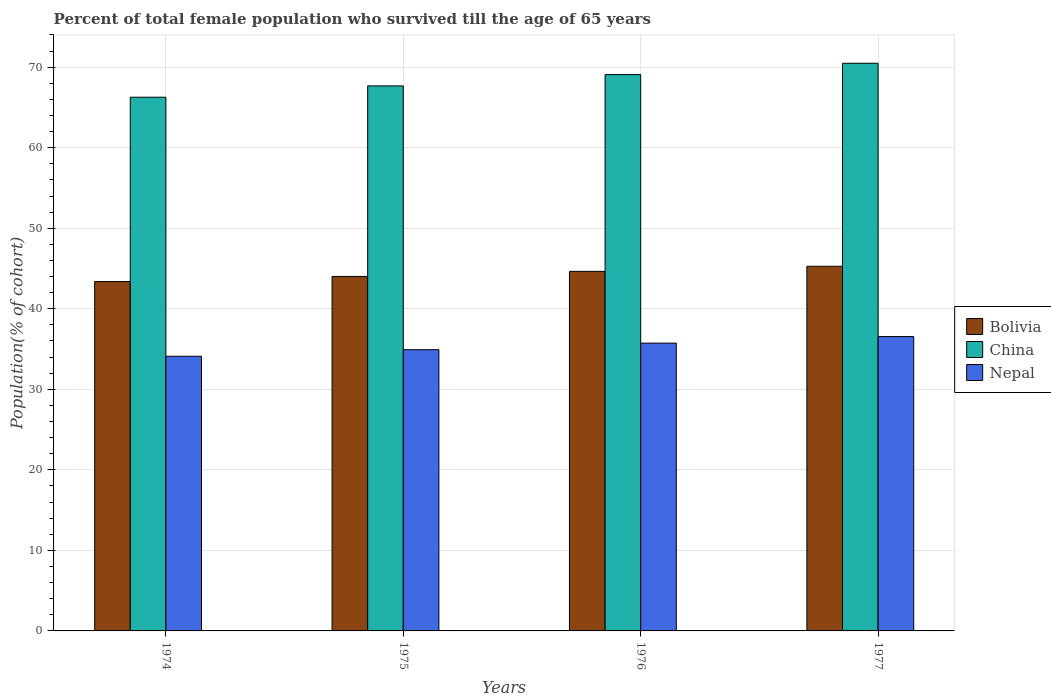Are the number of bars per tick equal to the number of legend labels?
Keep it short and to the point. Yes. Are the number of bars on each tick of the X-axis equal?
Offer a very short reply. Yes. How many bars are there on the 3rd tick from the right?
Make the answer very short. 3. What is the label of the 1st group of bars from the left?
Keep it short and to the point. 1974. In how many cases, is the number of bars for a given year not equal to the number of legend labels?
Keep it short and to the point. 0. What is the percentage of total female population who survived till the age of 65 years in China in 1976?
Offer a very short reply. 69.08. Across all years, what is the maximum percentage of total female population who survived till the age of 65 years in Bolivia?
Your answer should be compact. 45.27. Across all years, what is the minimum percentage of total female population who survived till the age of 65 years in Nepal?
Make the answer very short. 34.1. In which year was the percentage of total female population who survived till the age of 65 years in China minimum?
Provide a succinct answer. 1974. What is the total percentage of total female population who survived till the age of 65 years in Bolivia in the graph?
Your answer should be compact. 177.31. What is the difference between the percentage of total female population who survived till the age of 65 years in China in 1976 and that in 1977?
Give a very brief answer. -1.41. What is the difference between the percentage of total female population who survived till the age of 65 years in Nepal in 1977 and the percentage of total female population who survived till the age of 65 years in Bolivia in 1974?
Your answer should be very brief. -6.83. What is the average percentage of total female population who survived till the age of 65 years in Nepal per year?
Keep it short and to the point. 35.33. In the year 1974, what is the difference between the percentage of total female population who survived till the age of 65 years in Nepal and percentage of total female population who survived till the age of 65 years in China?
Your response must be concise. -32.16. What is the ratio of the percentage of total female population who survived till the age of 65 years in Bolivia in 1974 to that in 1975?
Provide a short and direct response. 0.99. Is the difference between the percentage of total female population who survived till the age of 65 years in Nepal in 1974 and 1975 greater than the difference between the percentage of total female population who survived till the age of 65 years in China in 1974 and 1975?
Ensure brevity in your answer.  Yes. What is the difference between the highest and the second highest percentage of total female population who survived till the age of 65 years in China?
Make the answer very short. 1.41. What is the difference between the highest and the lowest percentage of total female population who survived till the age of 65 years in Bolivia?
Your answer should be very brief. 1.89. In how many years, is the percentage of total female population who survived till the age of 65 years in Nepal greater than the average percentage of total female population who survived till the age of 65 years in Nepal taken over all years?
Your answer should be very brief. 2. Is the sum of the percentage of total female population who survived till the age of 65 years in Bolivia in 1975 and 1976 greater than the maximum percentage of total female population who survived till the age of 65 years in China across all years?
Keep it short and to the point. Yes. What does the 1st bar from the left in 1975 represents?
Ensure brevity in your answer.  Bolivia. What does the 3rd bar from the right in 1977 represents?
Your answer should be compact. Bolivia. Is it the case that in every year, the sum of the percentage of total female population who survived till the age of 65 years in Bolivia and percentage of total female population who survived till the age of 65 years in Nepal is greater than the percentage of total female population who survived till the age of 65 years in China?
Make the answer very short. Yes. How many bars are there?
Keep it short and to the point. 12. Are all the bars in the graph horizontal?
Offer a terse response. No. How many years are there in the graph?
Your answer should be compact. 4. Are the values on the major ticks of Y-axis written in scientific E-notation?
Your answer should be very brief. No. Does the graph contain any zero values?
Keep it short and to the point. No. Where does the legend appear in the graph?
Offer a very short reply. Center right. What is the title of the graph?
Provide a succinct answer. Percent of total female population who survived till the age of 65 years. What is the label or title of the Y-axis?
Offer a very short reply. Population(% of cohort). What is the Population(% of cohort) in Bolivia in 1974?
Your response must be concise. 43.38. What is the Population(% of cohort) in China in 1974?
Offer a very short reply. 66.27. What is the Population(% of cohort) of Nepal in 1974?
Your response must be concise. 34.1. What is the Population(% of cohort) in Bolivia in 1975?
Make the answer very short. 44.01. What is the Population(% of cohort) in China in 1975?
Offer a very short reply. 67.67. What is the Population(% of cohort) of Nepal in 1975?
Keep it short and to the point. 34.92. What is the Population(% of cohort) in Bolivia in 1976?
Keep it short and to the point. 44.64. What is the Population(% of cohort) in China in 1976?
Give a very brief answer. 69.08. What is the Population(% of cohort) in Nepal in 1976?
Provide a short and direct response. 35.73. What is the Population(% of cohort) in Bolivia in 1977?
Provide a succinct answer. 45.27. What is the Population(% of cohort) in China in 1977?
Provide a succinct answer. 70.48. What is the Population(% of cohort) of Nepal in 1977?
Ensure brevity in your answer.  36.55. Across all years, what is the maximum Population(% of cohort) in Bolivia?
Ensure brevity in your answer.  45.27. Across all years, what is the maximum Population(% of cohort) of China?
Provide a short and direct response. 70.48. Across all years, what is the maximum Population(% of cohort) in Nepal?
Your answer should be very brief. 36.55. Across all years, what is the minimum Population(% of cohort) in Bolivia?
Make the answer very short. 43.38. Across all years, what is the minimum Population(% of cohort) in China?
Offer a very short reply. 66.27. Across all years, what is the minimum Population(% of cohort) in Nepal?
Make the answer very short. 34.1. What is the total Population(% of cohort) in Bolivia in the graph?
Provide a short and direct response. 177.31. What is the total Population(% of cohort) in China in the graph?
Make the answer very short. 273.5. What is the total Population(% of cohort) in Nepal in the graph?
Ensure brevity in your answer.  141.31. What is the difference between the Population(% of cohort) of Bolivia in 1974 and that in 1975?
Provide a short and direct response. -0.63. What is the difference between the Population(% of cohort) in China in 1974 and that in 1975?
Offer a terse response. -1.41. What is the difference between the Population(% of cohort) in Nepal in 1974 and that in 1975?
Ensure brevity in your answer.  -0.81. What is the difference between the Population(% of cohort) in Bolivia in 1974 and that in 1976?
Keep it short and to the point. -1.26. What is the difference between the Population(% of cohort) of China in 1974 and that in 1976?
Your answer should be compact. -2.81. What is the difference between the Population(% of cohort) of Nepal in 1974 and that in 1976?
Your answer should be very brief. -1.63. What is the difference between the Population(% of cohort) of Bolivia in 1974 and that in 1977?
Make the answer very short. -1.89. What is the difference between the Population(% of cohort) of China in 1974 and that in 1977?
Make the answer very short. -4.22. What is the difference between the Population(% of cohort) in Nepal in 1974 and that in 1977?
Offer a terse response. -2.44. What is the difference between the Population(% of cohort) in Bolivia in 1975 and that in 1976?
Offer a very short reply. -0.63. What is the difference between the Population(% of cohort) of China in 1975 and that in 1976?
Ensure brevity in your answer.  -1.41. What is the difference between the Population(% of cohort) of Nepal in 1975 and that in 1976?
Ensure brevity in your answer.  -0.81. What is the difference between the Population(% of cohort) in Bolivia in 1975 and that in 1977?
Your answer should be very brief. -1.26. What is the difference between the Population(% of cohort) in China in 1975 and that in 1977?
Keep it short and to the point. -2.81. What is the difference between the Population(% of cohort) in Nepal in 1975 and that in 1977?
Your response must be concise. -1.63. What is the difference between the Population(% of cohort) in Bolivia in 1976 and that in 1977?
Ensure brevity in your answer.  -0.63. What is the difference between the Population(% of cohort) in China in 1976 and that in 1977?
Your answer should be very brief. -1.41. What is the difference between the Population(% of cohort) in Nepal in 1976 and that in 1977?
Offer a terse response. -0.81. What is the difference between the Population(% of cohort) in Bolivia in 1974 and the Population(% of cohort) in China in 1975?
Offer a terse response. -24.29. What is the difference between the Population(% of cohort) in Bolivia in 1974 and the Population(% of cohort) in Nepal in 1975?
Give a very brief answer. 8.46. What is the difference between the Population(% of cohort) of China in 1974 and the Population(% of cohort) of Nepal in 1975?
Offer a very short reply. 31.35. What is the difference between the Population(% of cohort) of Bolivia in 1974 and the Population(% of cohort) of China in 1976?
Provide a succinct answer. -25.7. What is the difference between the Population(% of cohort) in Bolivia in 1974 and the Population(% of cohort) in Nepal in 1976?
Give a very brief answer. 7.65. What is the difference between the Population(% of cohort) in China in 1974 and the Population(% of cohort) in Nepal in 1976?
Provide a succinct answer. 30.53. What is the difference between the Population(% of cohort) in Bolivia in 1974 and the Population(% of cohort) in China in 1977?
Provide a short and direct response. -27.1. What is the difference between the Population(% of cohort) of Bolivia in 1974 and the Population(% of cohort) of Nepal in 1977?
Provide a short and direct response. 6.83. What is the difference between the Population(% of cohort) in China in 1974 and the Population(% of cohort) in Nepal in 1977?
Offer a terse response. 29.72. What is the difference between the Population(% of cohort) in Bolivia in 1975 and the Population(% of cohort) in China in 1976?
Provide a short and direct response. -25.07. What is the difference between the Population(% of cohort) in Bolivia in 1975 and the Population(% of cohort) in Nepal in 1976?
Make the answer very short. 8.28. What is the difference between the Population(% of cohort) of China in 1975 and the Population(% of cohort) of Nepal in 1976?
Provide a succinct answer. 31.94. What is the difference between the Population(% of cohort) in Bolivia in 1975 and the Population(% of cohort) in China in 1977?
Ensure brevity in your answer.  -26.47. What is the difference between the Population(% of cohort) of Bolivia in 1975 and the Population(% of cohort) of Nepal in 1977?
Offer a very short reply. 7.46. What is the difference between the Population(% of cohort) of China in 1975 and the Population(% of cohort) of Nepal in 1977?
Give a very brief answer. 31.12. What is the difference between the Population(% of cohort) of Bolivia in 1976 and the Population(% of cohort) of China in 1977?
Offer a very short reply. -25.84. What is the difference between the Population(% of cohort) in Bolivia in 1976 and the Population(% of cohort) in Nepal in 1977?
Ensure brevity in your answer.  8.1. What is the difference between the Population(% of cohort) in China in 1976 and the Population(% of cohort) in Nepal in 1977?
Offer a terse response. 32.53. What is the average Population(% of cohort) of Bolivia per year?
Keep it short and to the point. 44.33. What is the average Population(% of cohort) of China per year?
Offer a terse response. 68.37. What is the average Population(% of cohort) of Nepal per year?
Provide a succinct answer. 35.33. In the year 1974, what is the difference between the Population(% of cohort) of Bolivia and Population(% of cohort) of China?
Give a very brief answer. -22.88. In the year 1974, what is the difference between the Population(% of cohort) of Bolivia and Population(% of cohort) of Nepal?
Offer a terse response. 9.28. In the year 1974, what is the difference between the Population(% of cohort) of China and Population(% of cohort) of Nepal?
Your answer should be very brief. 32.16. In the year 1975, what is the difference between the Population(% of cohort) in Bolivia and Population(% of cohort) in China?
Ensure brevity in your answer.  -23.66. In the year 1975, what is the difference between the Population(% of cohort) in Bolivia and Population(% of cohort) in Nepal?
Offer a very short reply. 9.09. In the year 1975, what is the difference between the Population(% of cohort) of China and Population(% of cohort) of Nepal?
Give a very brief answer. 32.75. In the year 1976, what is the difference between the Population(% of cohort) of Bolivia and Population(% of cohort) of China?
Offer a terse response. -24.43. In the year 1976, what is the difference between the Population(% of cohort) of Bolivia and Population(% of cohort) of Nepal?
Offer a very short reply. 8.91. In the year 1976, what is the difference between the Population(% of cohort) of China and Population(% of cohort) of Nepal?
Your response must be concise. 33.34. In the year 1977, what is the difference between the Population(% of cohort) in Bolivia and Population(% of cohort) in China?
Offer a very short reply. -25.21. In the year 1977, what is the difference between the Population(% of cohort) of Bolivia and Population(% of cohort) of Nepal?
Your response must be concise. 8.73. In the year 1977, what is the difference between the Population(% of cohort) of China and Population(% of cohort) of Nepal?
Keep it short and to the point. 33.94. What is the ratio of the Population(% of cohort) in Bolivia in 1974 to that in 1975?
Ensure brevity in your answer.  0.99. What is the ratio of the Population(% of cohort) in China in 1974 to that in 1975?
Ensure brevity in your answer.  0.98. What is the ratio of the Population(% of cohort) of Nepal in 1974 to that in 1975?
Provide a short and direct response. 0.98. What is the ratio of the Population(% of cohort) in Bolivia in 1974 to that in 1976?
Make the answer very short. 0.97. What is the ratio of the Population(% of cohort) in China in 1974 to that in 1976?
Offer a terse response. 0.96. What is the ratio of the Population(% of cohort) in Nepal in 1974 to that in 1976?
Your answer should be very brief. 0.95. What is the ratio of the Population(% of cohort) in Bolivia in 1974 to that in 1977?
Offer a very short reply. 0.96. What is the ratio of the Population(% of cohort) of China in 1974 to that in 1977?
Offer a very short reply. 0.94. What is the ratio of the Population(% of cohort) of Nepal in 1974 to that in 1977?
Your response must be concise. 0.93. What is the ratio of the Population(% of cohort) in Bolivia in 1975 to that in 1976?
Provide a succinct answer. 0.99. What is the ratio of the Population(% of cohort) of China in 1975 to that in 1976?
Offer a terse response. 0.98. What is the ratio of the Population(% of cohort) in Nepal in 1975 to that in 1976?
Offer a terse response. 0.98. What is the ratio of the Population(% of cohort) in Bolivia in 1975 to that in 1977?
Your answer should be compact. 0.97. What is the ratio of the Population(% of cohort) of China in 1975 to that in 1977?
Provide a succinct answer. 0.96. What is the ratio of the Population(% of cohort) in Nepal in 1975 to that in 1977?
Make the answer very short. 0.96. What is the ratio of the Population(% of cohort) in Bolivia in 1976 to that in 1977?
Your response must be concise. 0.99. What is the ratio of the Population(% of cohort) of China in 1976 to that in 1977?
Ensure brevity in your answer.  0.98. What is the ratio of the Population(% of cohort) of Nepal in 1976 to that in 1977?
Your answer should be compact. 0.98. What is the difference between the highest and the second highest Population(% of cohort) in Bolivia?
Give a very brief answer. 0.63. What is the difference between the highest and the second highest Population(% of cohort) in China?
Make the answer very short. 1.41. What is the difference between the highest and the second highest Population(% of cohort) of Nepal?
Keep it short and to the point. 0.81. What is the difference between the highest and the lowest Population(% of cohort) in Bolivia?
Provide a short and direct response. 1.89. What is the difference between the highest and the lowest Population(% of cohort) in China?
Provide a succinct answer. 4.22. What is the difference between the highest and the lowest Population(% of cohort) in Nepal?
Keep it short and to the point. 2.44. 